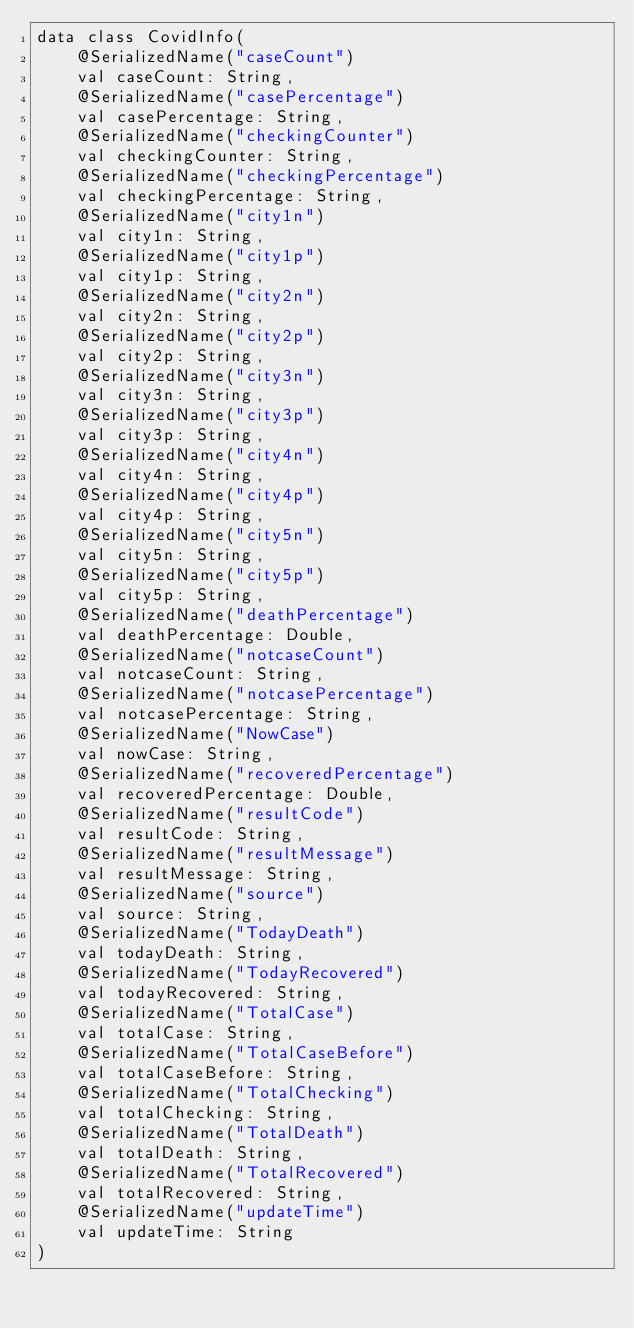Convert code to text. <code><loc_0><loc_0><loc_500><loc_500><_Kotlin_>data class CovidInfo(
    @SerializedName("caseCount")
    val caseCount: String,
    @SerializedName("casePercentage")
    val casePercentage: String,
    @SerializedName("checkingCounter")
    val checkingCounter: String,
    @SerializedName("checkingPercentage")
    val checkingPercentage: String,
    @SerializedName("city1n")
    val city1n: String,
    @SerializedName("city1p")
    val city1p: String,
    @SerializedName("city2n")
    val city2n: String,
    @SerializedName("city2p")
    val city2p: String,
    @SerializedName("city3n")
    val city3n: String,
    @SerializedName("city3p")
    val city3p: String,
    @SerializedName("city4n")
    val city4n: String,
    @SerializedName("city4p")
    val city4p: String,
    @SerializedName("city5n")
    val city5n: String,
    @SerializedName("city5p")
    val city5p: String,
    @SerializedName("deathPercentage")
    val deathPercentage: Double,
    @SerializedName("notcaseCount")
    val notcaseCount: String,
    @SerializedName("notcasePercentage")
    val notcasePercentage: String,
    @SerializedName("NowCase")
    val nowCase: String,
    @SerializedName("recoveredPercentage")
    val recoveredPercentage: Double,
    @SerializedName("resultCode")
    val resultCode: String,
    @SerializedName("resultMessage")
    val resultMessage: String,
    @SerializedName("source")
    val source: String,
    @SerializedName("TodayDeath")
    val todayDeath: String,
    @SerializedName("TodayRecovered")
    val todayRecovered: String,
    @SerializedName("TotalCase")
    val totalCase: String,
    @SerializedName("TotalCaseBefore")
    val totalCaseBefore: String,
    @SerializedName("TotalChecking")
    val totalChecking: String,
    @SerializedName("TotalDeath")
    val totalDeath: String,
    @SerializedName("TotalRecovered")
    val totalRecovered: String,
    @SerializedName("updateTime")
    val updateTime: String
)</code> 